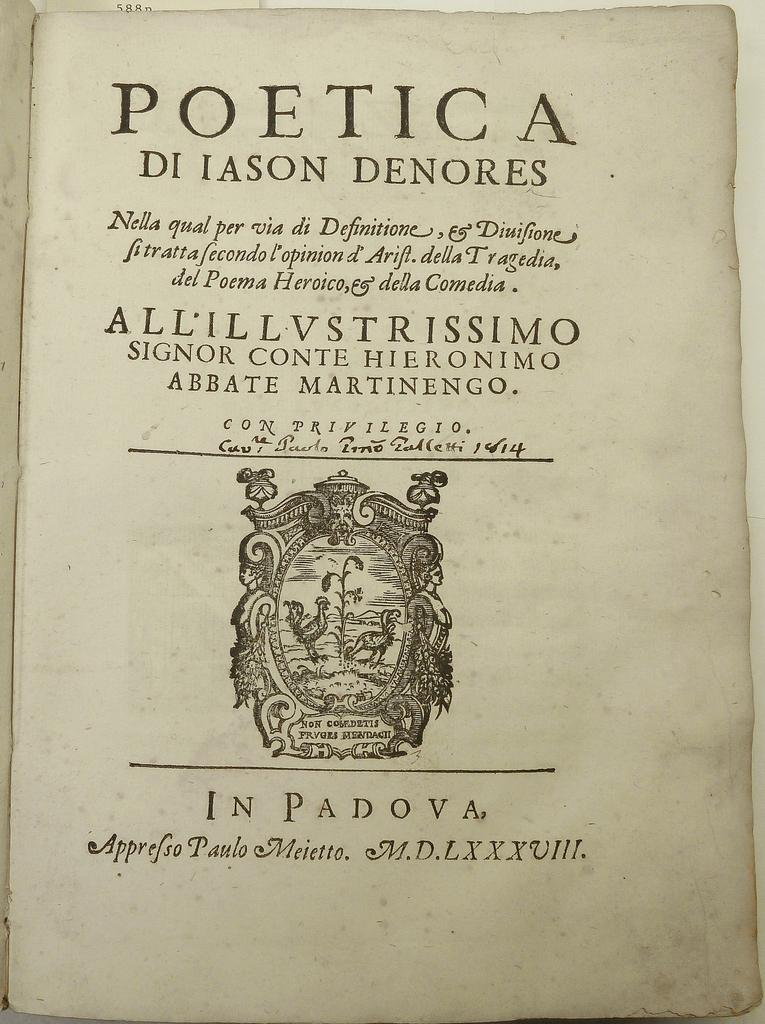<image>
Create a compact narrative representing the image presented. the cover page of the book titled Poetica by Di iason Denores. 